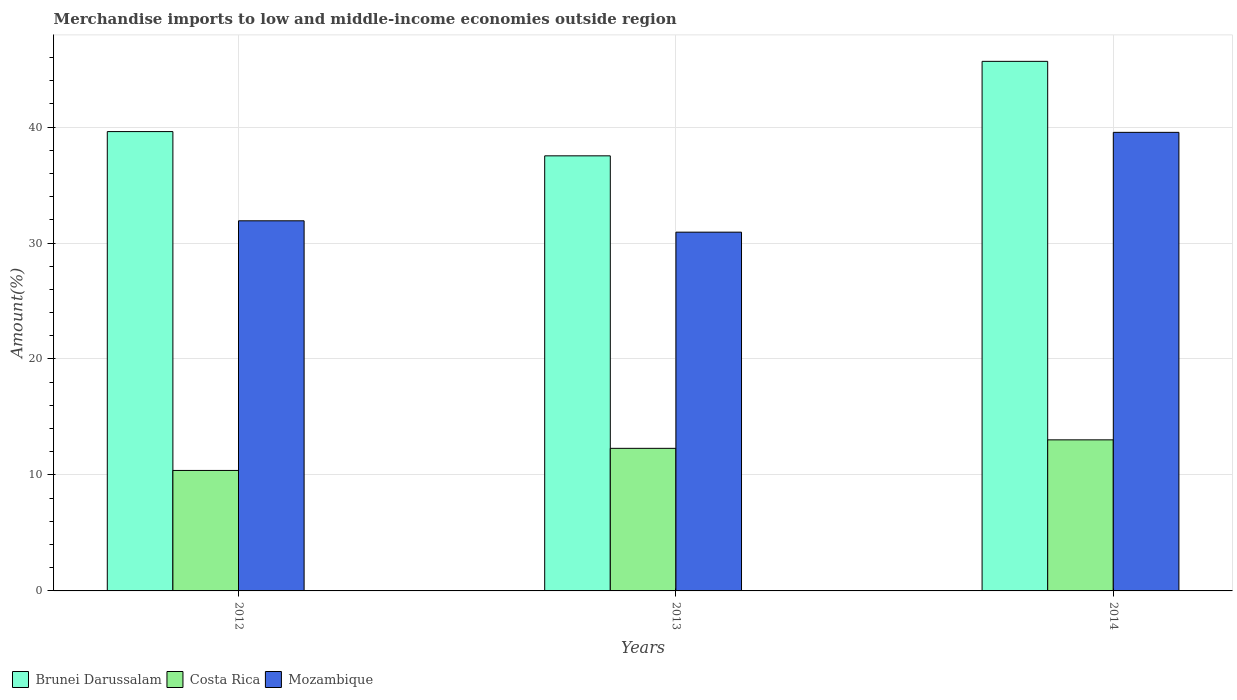How many different coloured bars are there?
Provide a short and direct response. 3. How many groups of bars are there?
Offer a terse response. 3. Are the number of bars on each tick of the X-axis equal?
Your response must be concise. Yes. How many bars are there on the 1st tick from the left?
Your answer should be very brief. 3. How many bars are there on the 3rd tick from the right?
Your response must be concise. 3. In how many cases, is the number of bars for a given year not equal to the number of legend labels?
Your response must be concise. 0. What is the percentage of amount earned from merchandise imports in Brunei Darussalam in 2013?
Your answer should be compact. 37.52. Across all years, what is the maximum percentage of amount earned from merchandise imports in Brunei Darussalam?
Offer a very short reply. 45.66. Across all years, what is the minimum percentage of amount earned from merchandise imports in Mozambique?
Provide a short and direct response. 30.93. In which year was the percentage of amount earned from merchandise imports in Brunei Darussalam maximum?
Provide a succinct answer. 2014. In which year was the percentage of amount earned from merchandise imports in Mozambique minimum?
Your answer should be compact. 2013. What is the total percentage of amount earned from merchandise imports in Brunei Darussalam in the graph?
Your answer should be compact. 122.79. What is the difference between the percentage of amount earned from merchandise imports in Brunei Darussalam in 2012 and that in 2014?
Provide a short and direct response. -6.06. What is the difference between the percentage of amount earned from merchandise imports in Brunei Darussalam in 2014 and the percentage of amount earned from merchandise imports in Costa Rica in 2013?
Your answer should be very brief. 33.37. What is the average percentage of amount earned from merchandise imports in Costa Rica per year?
Offer a very short reply. 11.9. In the year 2012, what is the difference between the percentage of amount earned from merchandise imports in Brunei Darussalam and percentage of amount earned from merchandise imports in Mozambique?
Offer a very short reply. 7.69. In how many years, is the percentage of amount earned from merchandise imports in Mozambique greater than 40 %?
Keep it short and to the point. 0. What is the ratio of the percentage of amount earned from merchandise imports in Costa Rica in 2012 to that in 2014?
Your response must be concise. 0.8. Is the difference between the percentage of amount earned from merchandise imports in Brunei Darussalam in 2012 and 2014 greater than the difference between the percentage of amount earned from merchandise imports in Mozambique in 2012 and 2014?
Ensure brevity in your answer.  Yes. What is the difference between the highest and the second highest percentage of amount earned from merchandise imports in Costa Rica?
Give a very brief answer. 0.73. What is the difference between the highest and the lowest percentage of amount earned from merchandise imports in Costa Rica?
Provide a succinct answer. 2.64. In how many years, is the percentage of amount earned from merchandise imports in Costa Rica greater than the average percentage of amount earned from merchandise imports in Costa Rica taken over all years?
Keep it short and to the point. 2. What does the 2nd bar from the left in 2013 represents?
Provide a succinct answer. Costa Rica. How many bars are there?
Offer a terse response. 9. Are all the bars in the graph horizontal?
Give a very brief answer. No. How many years are there in the graph?
Keep it short and to the point. 3. Are the values on the major ticks of Y-axis written in scientific E-notation?
Provide a succinct answer. No. Does the graph contain grids?
Your answer should be compact. Yes. Where does the legend appear in the graph?
Give a very brief answer. Bottom left. How many legend labels are there?
Ensure brevity in your answer.  3. How are the legend labels stacked?
Your answer should be compact. Horizontal. What is the title of the graph?
Ensure brevity in your answer.  Merchandise imports to low and middle-income economies outside region. What is the label or title of the X-axis?
Offer a terse response. Years. What is the label or title of the Y-axis?
Your answer should be compact. Amount(%). What is the Amount(%) in Brunei Darussalam in 2012?
Provide a succinct answer. 39.61. What is the Amount(%) of Costa Rica in 2012?
Keep it short and to the point. 10.39. What is the Amount(%) of Mozambique in 2012?
Offer a terse response. 31.91. What is the Amount(%) of Brunei Darussalam in 2013?
Your answer should be very brief. 37.52. What is the Amount(%) of Costa Rica in 2013?
Provide a succinct answer. 12.29. What is the Amount(%) in Mozambique in 2013?
Provide a short and direct response. 30.93. What is the Amount(%) of Brunei Darussalam in 2014?
Your answer should be very brief. 45.66. What is the Amount(%) of Costa Rica in 2014?
Make the answer very short. 13.03. What is the Amount(%) of Mozambique in 2014?
Ensure brevity in your answer.  39.54. Across all years, what is the maximum Amount(%) of Brunei Darussalam?
Offer a terse response. 45.66. Across all years, what is the maximum Amount(%) of Costa Rica?
Your answer should be very brief. 13.03. Across all years, what is the maximum Amount(%) of Mozambique?
Give a very brief answer. 39.54. Across all years, what is the minimum Amount(%) in Brunei Darussalam?
Offer a terse response. 37.52. Across all years, what is the minimum Amount(%) of Costa Rica?
Your answer should be very brief. 10.39. Across all years, what is the minimum Amount(%) in Mozambique?
Provide a succinct answer. 30.93. What is the total Amount(%) in Brunei Darussalam in the graph?
Provide a succinct answer. 122.79. What is the total Amount(%) in Costa Rica in the graph?
Make the answer very short. 35.71. What is the total Amount(%) in Mozambique in the graph?
Keep it short and to the point. 102.39. What is the difference between the Amount(%) of Brunei Darussalam in 2012 and that in 2013?
Make the answer very short. 2.09. What is the difference between the Amount(%) of Costa Rica in 2012 and that in 2013?
Your response must be concise. -1.91. What is the difference between the Amount(%) in Mozambique in 2012 and that in 2013?
Offer a very short reply. 0.98. What is the difference between the Amount(%) in Brunei Darussalam in 2012 and that in 2014?
Your answer should be compact. -6.06. What is the difference between the Amount(%) in Costa Rica in 2012 and that in 2014?
Offer a terse response. -2.64. What is the difference between the Amount(%) in Mozambique in 2012 and that in 2014?
Make the answer very short. -7.63. What is the difference between the Amount(%) in Brunei Darussalam in 2013 and that in 2014?
Your answer should be very brief. -8.15. What is the difference between the Amount(%) in Costa Rica in 2013 and that in 2014?
Your answer should be very brief. -0.73. What is the difference between the Amount(%) of Mozambique in 2013 and that in 2014?
Give a very brief answer. -8.61. What is the difference between the Amount(%) in Brunei Darussalam in 2012 and the Amount(%) in Costa Rica in 2013?
Your response must be concise. 27.31. What is the difference between the Amount(%) of Brunei Darussalam in 2012 and the Amount(%) of Mozambique in 2013?
Provide a succinct answer. 8.67. What is the difference between the Amount(%) in Costa Rica in 2012 and the Amount(%) in Mozambique in 2013?
Ensure brevity in your answer.  -20.55. What is the difference between the Amount(%) of Brunei Darussalam in 2012 and the Amount(%) of Costa Rica in 2014?
Give a very brief answer. 26.58. What is the difference between the Amount(%) of Brunei Darussalam in 2012 and the Amount(%) of Mozambique in 2014?
Give a very brief answer. 0.07. What is the difference between the Amount(%) of Costa Rica in 2012 and the Amount(%) of Mozambique in 2014?
Your response must be concise. -29.15. What is the difference between the Amount(%) in Brunei Darussalam in 2013 and the Amount(%) in Costa Rica in 2014?
Make the answer very short. 24.49. What is the difference between the Amount(%) of Brunei Darussalam in 2013 and the Amount(%) of Mozambique in 2014?
Offer a very short reply. -2.02. What is the difference between the Amount(%) of Costa Rica in 2013 and the Amount(%) of Mozambique in 2014?
Offer a terse response. -27.25. What is the average Amount(%) in Brunei Darussalam per year?
Provide a short and direct response. 40.93. What is the average Amount(%) in Costa Rica per year?
Your answer should be compact. 11.9. What is the average Amount(%) in Mozambique per year?
Offer a terse response. 34.13. In the year 2012, what is the difference between the Amount(%) in Brunei Darussalam and Amount(%) in Costa Rica?
Offer a very short reply. 29.22. In the year 2012, what is the difference between the Amount(%) in Brunei Darussalam and Amount(%) in Mozambique?
Give a very brief answer. 7.69. In the year 2012, what is the difference between the Amount(%) of Costa Rica and Amount(%) of Mozambique?
Give a very brief answer. -21.53. In the year 2013, what is the difference between the Amount(%) of Brunei Darussalam and Amount(%) of Costa Rica?
Ensure brevity in your answer.  25.22. In the year 2013, what is the difference between the Amount(%) of Brunei Darussalam and Amount(%) of Mozambique?
Your answer should be very brief. 6.58. In the year 2013, what is the difference between the Amount(%) in Costa Rica and Amount(%) in Mozambique?
Offer a very short reply. -18.64. In the year 2014, what is the difference between the Amount(%) in Brunei Darussalam and Amount(%) in Costa Rica?
Offer a terse response. 32.64. In the year 2014, what is the difference between the Amount(%) of Brunei Darussalam and Amount(%) of Mozambique?
Provide a succinct answer. 6.12. In the year 2014, what is the difference between the Amount(%) of Costa Rica and Amount(%) of Mozambique?
Make the answer very short. -26.52. What is the ratio of the Amount(%) of Brunei Darussalam in 2012 to that in 2013?
Your answer should be compact. 1.06. What is the ratio of the Amount(%) in Costa Rica in 2012 to that in 2013?
Your response must be concise. 0.84. What is the ratio of the Amount(%) in Mozambique in 2012 to that in 2013?
Offer a very short reply. 1.03. What is the ratio of the Amount(%) in Brunei Darussalam in 2012 to that in 2014?
Give a very brief answer. 0.87. What is the ratio of the Amount(%) of Costa Rica in 2012 to that in 2014?
Provide a short and direct response. 0.8. What is the ratio of the Amount(%) of Mozambique in 2012 to that in 2014?
Provide a succinct answer. 0.81. What is the ratio of the Amount(%) of Brunei Darussalam in 2013 to that in 2014?
Make the answer very short. 0.82. What is the ratio of the Amount(%) of Costa Rica in 2013 to that in 2014?
Ensure brevity in your answer.  0.94. What is the ratio of the Amount(%) of Mozambique in 2013 to that in 2014?
Your answer should be very brief. 0.78. What is the difference between the highest and the second highest Amount(%) of Brunei Darussalam?
Keep it short and to the point. 6.06. What is the difference between the highest and the second highest Amount(%) in Costa Rica?
Ensure brevity in your answer.  0.73. What is the difference between the highest and the second highest Amount(%) of Mozambique?
Offer a terse response. 7.63. What is the difference between the highest and the lowest Amount(%) in Brunei Darussalam?
Make the answer very short. 8.15. What is the difference between the highest and the lowest Amount(%) of Costa Rica?
Ensure brevity in your answer.  2.64. What is the difference between the highest and the lowest Amount(%) of Mozambique?
Give a very brief answer. 8.61. 